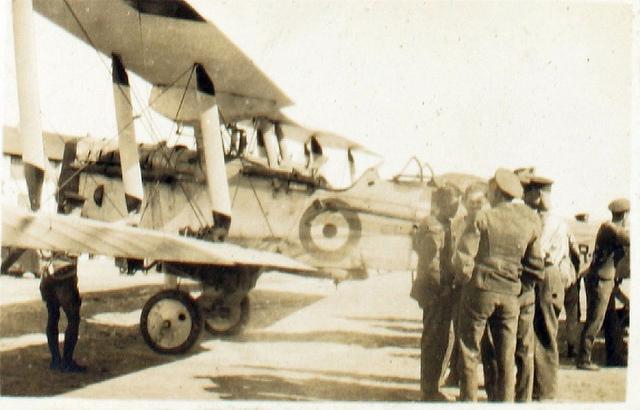Are one of these men going to fly the plane?
Give a very brief answer. Yes. Is there someone in the plane?
Answer briefly. No. From what country is this aircraft?
Write a very short answer. Germany. 